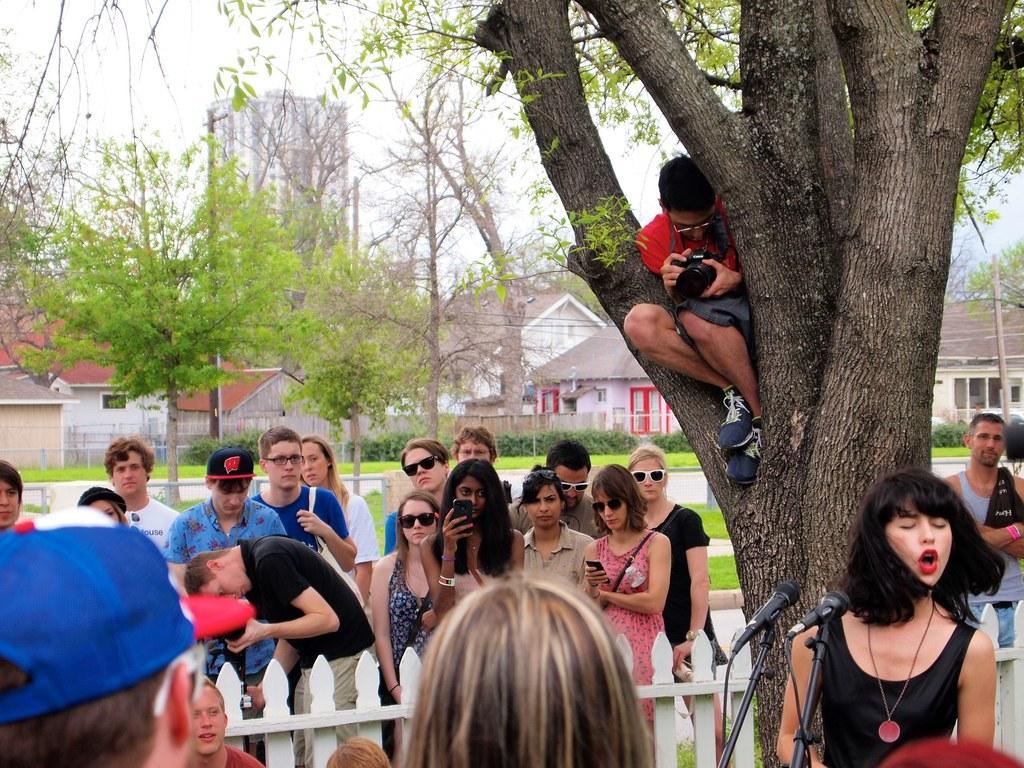Please provide a concise description of this image. In this image I can see number of people are standing. In the front I can see a tree, few mice and on the tree I can see a man and I can see he is holding a camera. In the background I can see number of buildings, few poles and few more trees. I can also see plants and grass in the background. 